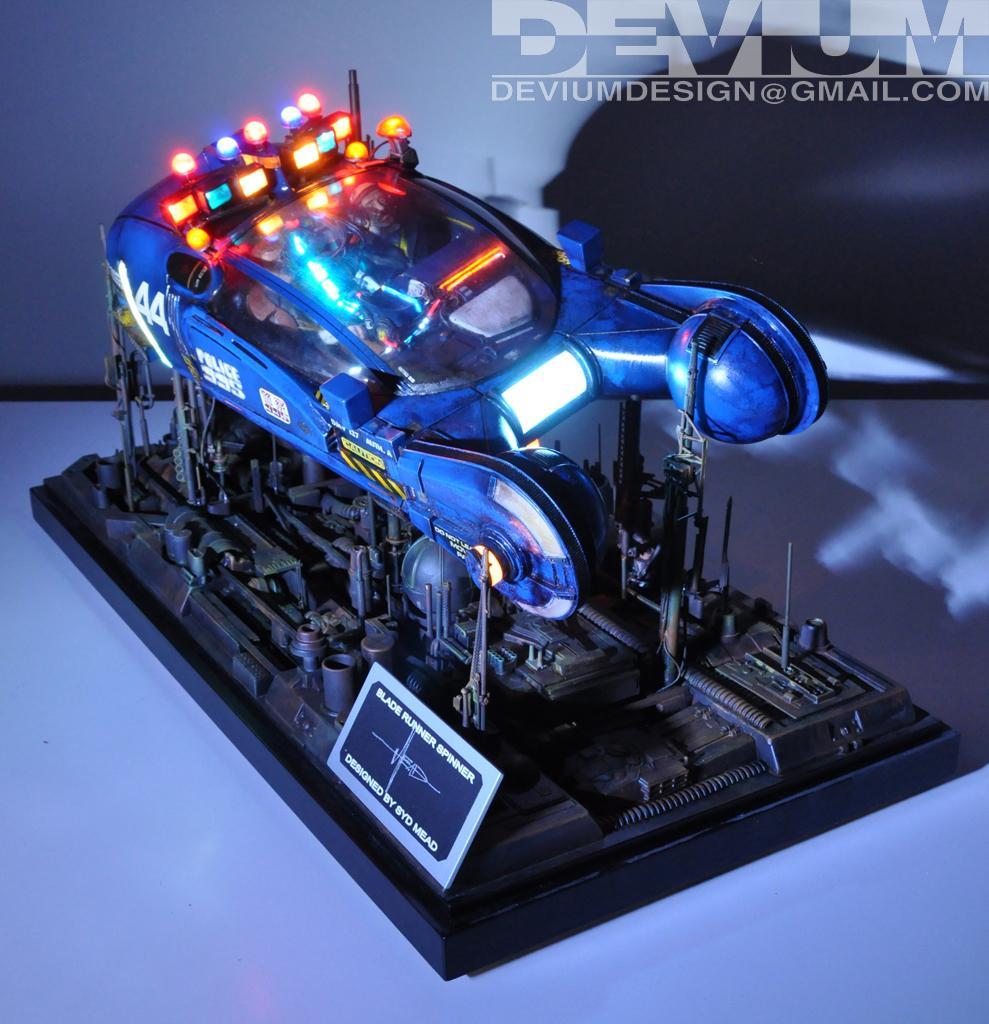Please provide a concise description of this image. In this image there is an object with lighting and it is placed on the white surface. At the top right corner we can see a text. 